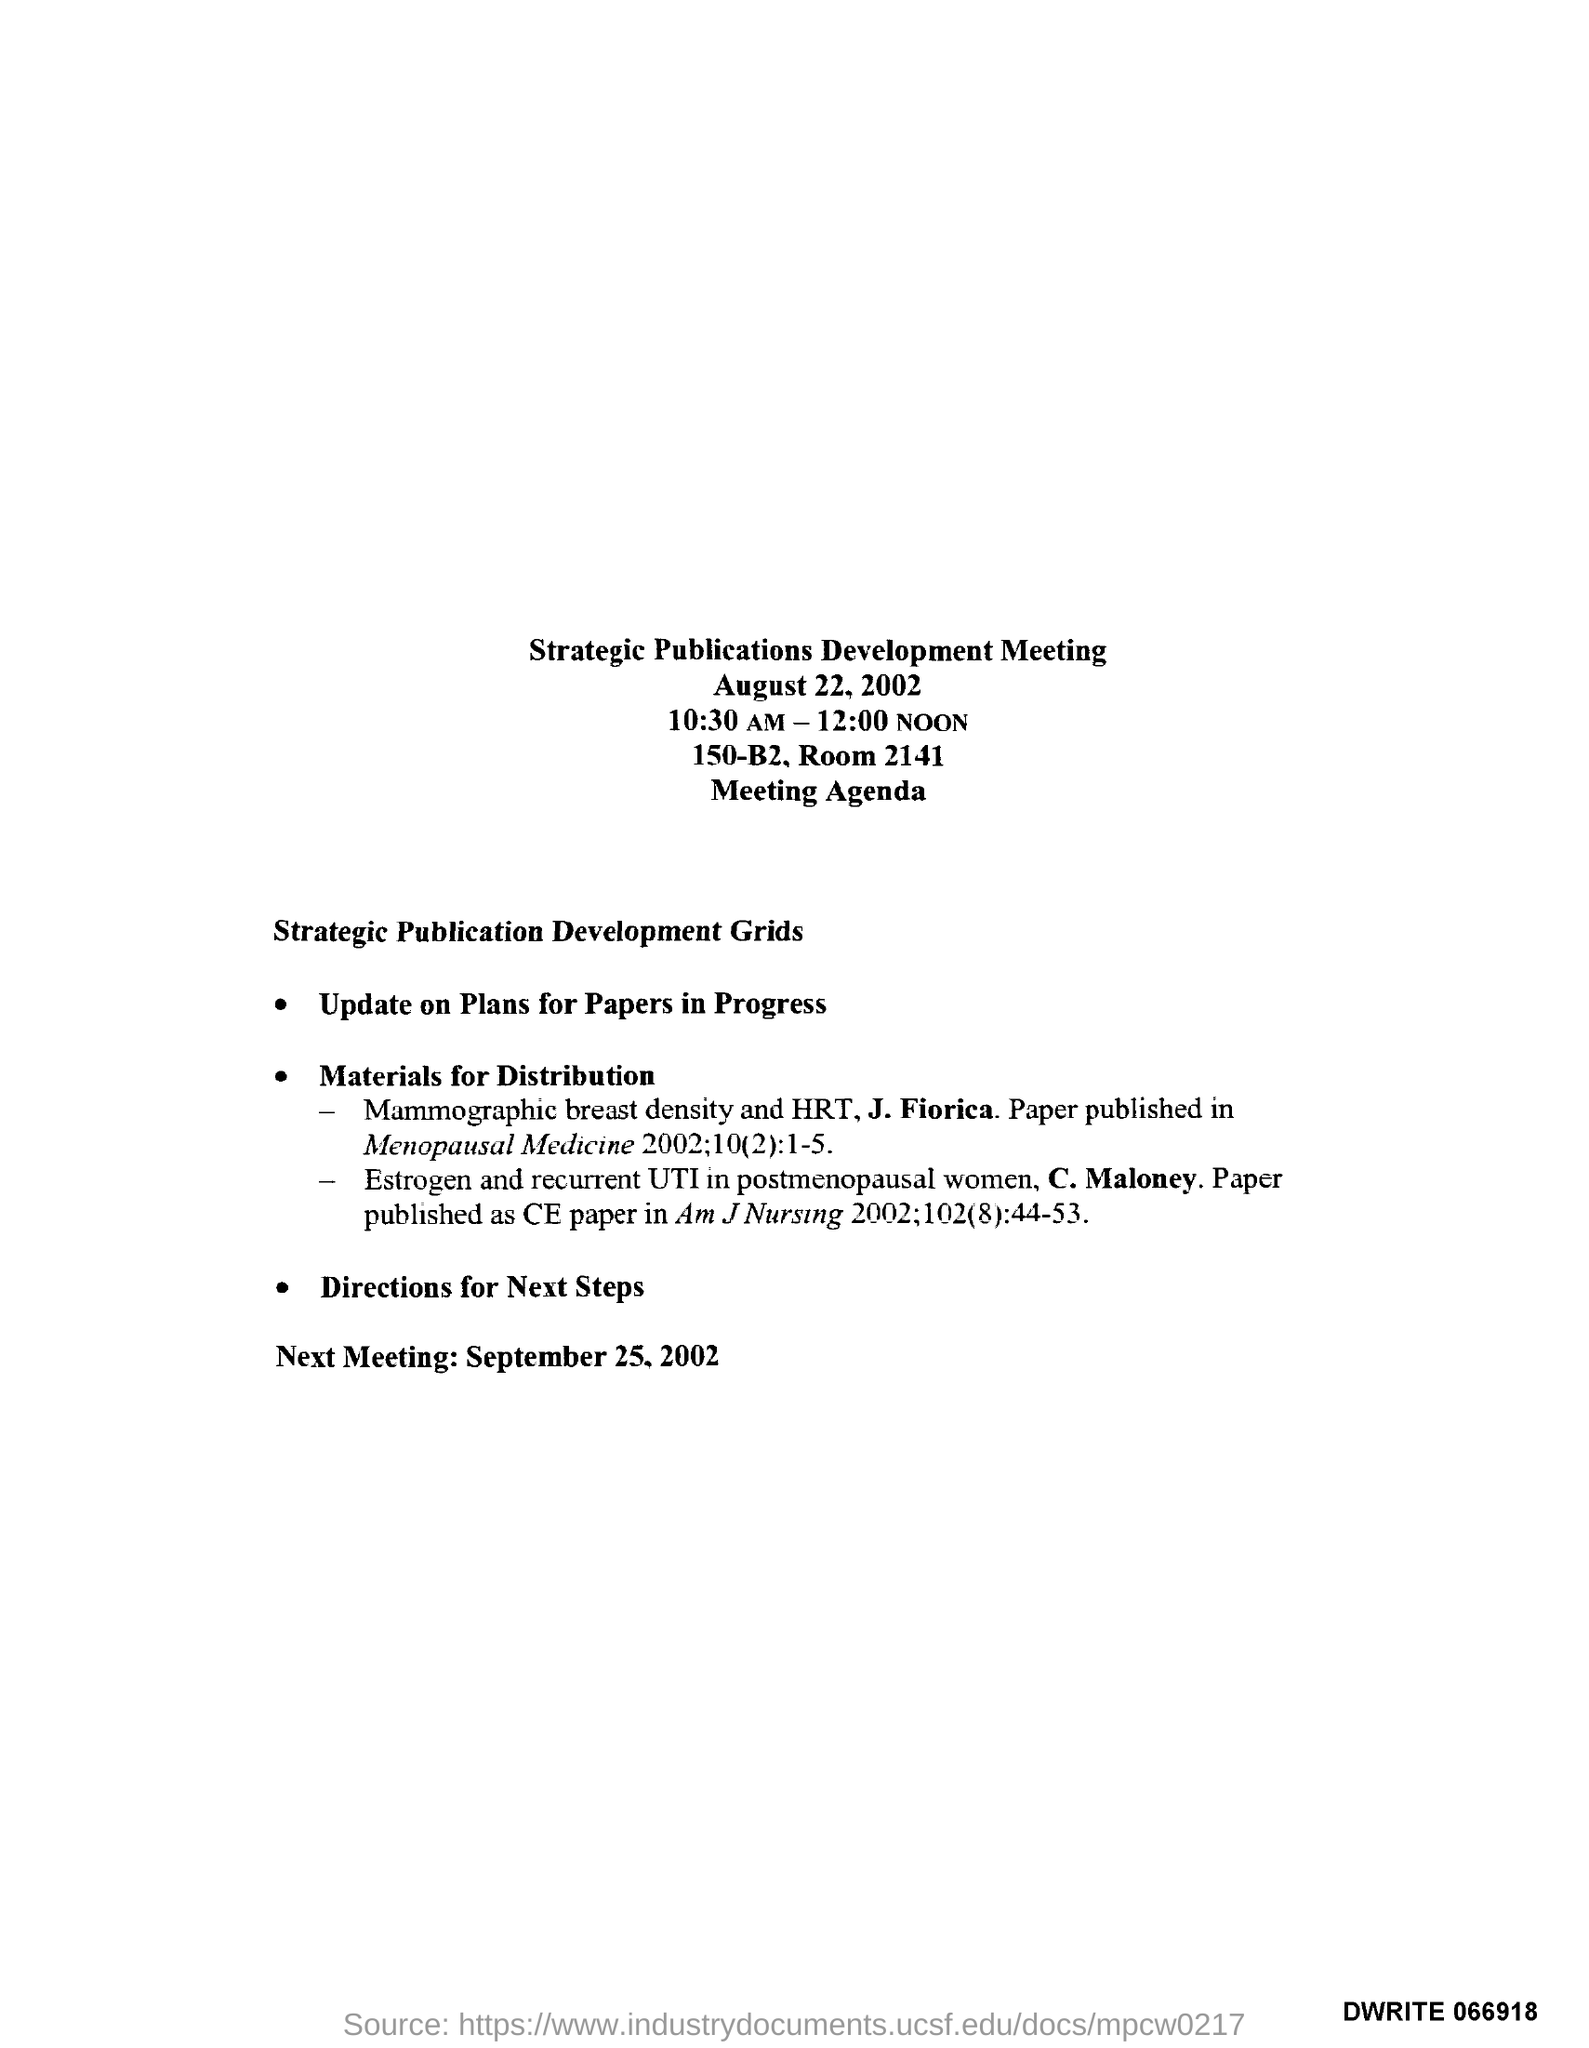Identify some key points in this picture. The date of the next meeting is September 25, 2002. The room number is 2141. 